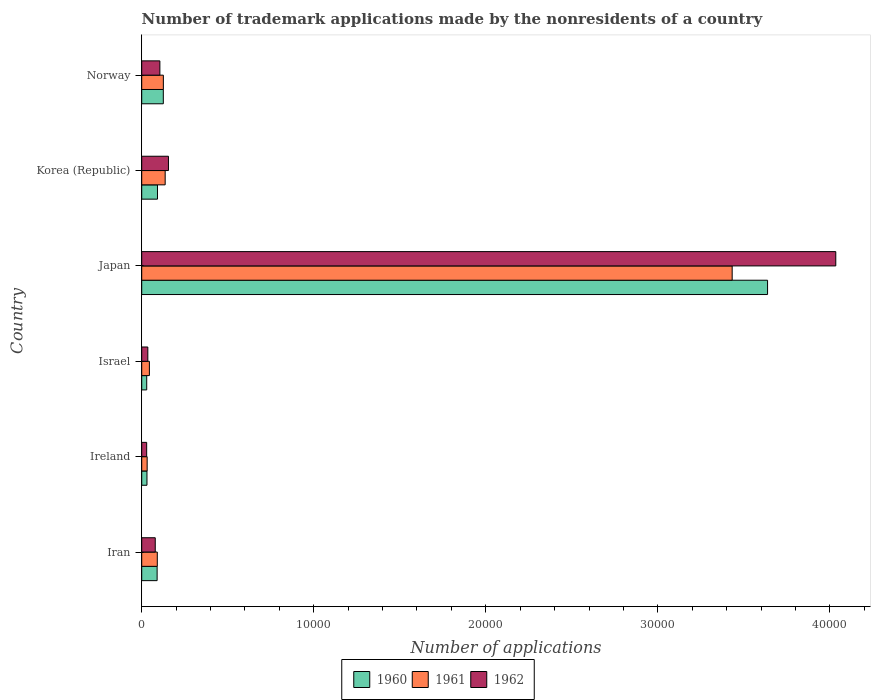How many groups of bars are there?
Give a very brief answer. 6. Are the number of bars per tick equal to the number of legend labels?
Give a very brief answer. Yes. How many bars are there on the 2nd tick from the top?
Provide a short and direct response. 3. How many bars are there on the 6th tick from the bottom?
Offer a very short reply. 3. What is the label of the 4th group of bars from the top?
Provide a short and direct response. Israel. What is the number of trademark applications made by the nonresidents in 1961 in Ireland?
Your response must be concise. 316. Across all countries, what is the maximum number of trademark applications made by the nonresidents in 1961?
Keep it short and to the point. 3.43e+04. Across all countries, what is the minimum number of trademark applications made by the nonresidents in 1962?
Keep it short and to the point. 288. In which country was the number of trademark applications made by the nonresidents in 1961 maximum?
Make the answer very short. Japan. In which country was the number of trademark applications made by the nonresidents in 1962 minimum?
Your answer should be very brief. Ireland. What is the total number of trademark applications made by the nonresidents in 1960 in the graph?
Ensure brevity in your answer.  4.00e+04. What is the difference between the number of trademark applications made by the nonresidents in 1961 in Japan and that in Norway?
Your answer should be compact. 3.31e+04. What is the difference between the number of trademark applications made by the nonresidents in 1961 in Israel and the number of trademark applications made by the nonresidents in 1962 in Iran?
Offer a terse response. -340. What is the average number of trademark applications made by the nonresidents in 1961 per country?
Keep it short and to the point. 6434.67. What is the difference between the number of trademark applications made by the nonresidents in 1962 and number of trademark applications made by the nonresidents in 1960 in Japan?
Your response must be concise. 3966. What is the ratio of the number of trademark applications made by the nonresidents in 1961 in Japan to that in Korea (Republic)?
Provide a short and direct response. 25.18. Is the number of trademark applications made by the nonresidents in 1960 in Israel less than that in Norway?
Provide a succinct answer. Yes. Is the difference between the number of trademark applications made by the nonresidents in 1962 in Iran and Korea (Republic) greater than the difference between the number of trademark applications made by the nonresidents in 1960 in Iran and Korea (Republic)?
Keep it short and to the point. No. What is the difference between the highest and the second highest number of trademark applications made by the nonresidents in 1960?
Give a very brief answer. 3.51e+04. What is the difference between the highest and the lowest number of trademark applications made by the nonresidents in 1961?
Offer a terse response. 3.40e+04. What does the 3rd bar from the bottom in Ireland represents?
Ensure brevity in your answer.  1962. How many bars are there?
Offer a terse response. 18. Are all the bars in the graph horizontal?
Give a very brief answer. Yes. What is the difference between two consecutive major ticks on the X-axis?
Offer a terse response. 10000. Does the graph contain any zero values?
Keep it short and to the point. No. Does the graph contain grids?
Your answer should be compact. No. What is the title of the graph?
Ensure brevity in your answer.  Number of trademark applications made by the nonresidents of a country. Does "2010" appear as one of the legend labels in the graph?
Provide a short and direct response. No. What is the label or title of the X-axis?
Keep it short and to the point. Number of applications. What is the label or title of the Y-axis?
Provide a short and direct response. Country. What is the Number of applications of 1960 in Iran?
Ensure brevity in your answer.  895. What is the Number of applications in 1961 in Iran?
Your answer should be very brief. 905. What is the Number of applications in 1962 in Iran?
Ensure brevity in your answer.  786. What is the Number of applications in 1960 in Ireland?
Your response must be concise. 305. What is the Number of applications of 1961 in Ireland?
Keep it short and to the point. 316. What is the Number of applications of 1962 in Ireland?
Give a very brief answer. 288. What is the Number of applications in 1960 in Israel?
Keep it short and to the point. 290. What is the Number of applications of 1961 in Israel?
Offer a terse response. 446. What is the Number of applications in 1962 in Israel?
Provide a succinct answer. 355. What is the Number of applications in 1960 in Japan?
Offer a very short reply. 3.64e+04. What is the Number of applications in 1961 in Japan?
Offer a terse response. 3.43e+04. What is the Number of applications in 1962 in Japan?
Give a very brief answer. 4.03e+04. What is the Number of applications of 1960 in Korea (Republic)?
Offer a very short reply. 916. What is the Number of applications in 1961 in Korea (Republic)?
Make the answer very short. 1363. What is the Number of applications of 1962 in Korea (Republic)?
Make the answer very short. 1554. What is the Number of applications in 1960 in Norway?
Your response must be concise. 1255. What is the Number of applications of 1961 in Norway?
Offer a very short reply. 1258. What is the Number of applications of 1962 in Norway?
Your response must be concise. 1055. Across all countries, what is the maximum Number of applications in 1960?
Your response must be concise. 3.64e+04. Across all countries, what is the maximum Number of applications in 1961?
Give a very brief answer. 3.43e+04. Across all countries, what is the maximum Number of applications of 1962?
Make the answer very short. 4.03e+04. Across all countries, what is the minimum Number of applications in 1960?
Make the answer very short. 290. Across all countries, what is the minimum Number of applications in 1961?
Give a very brief answer. 316. Across all countries, what is the minimum Number of applications in 1962?
Provide a short and direct response. 288. What is the total Number of applications of 1960 in the graph?
Ensure brevity in your answer.  4.00e+04. What is the total Number of applications of 1961 in the graph?
Provide a succinct answer. 3.86e+04. What is the total Number of applications of 1962 in the graph?
Provide a succinct answer. 4.44e+04. What is the difference between the Number of applications in 1960 in Iran and that in Ireland?
Your answer should be very brief. 590. What is the difference between the Number of applications of 1961 in Iran and that in Ireland?
Keep it short and to the point. 589. What is the difference between the Number of applications in 1962 in Iran and that in Ireland?
Keep it short and to the point. 498. What is the difference between the Number of applications of 1960 in Iran and that in Israel?
Offer a very short reply. 605. What is the difference between the Number of applications in 1961 in Iran and that in Israel?
Provide a succinct answer. 459. What is the difference between the Number of applications of 1962 in Iran and that in Israel?
Your answer should be compact. 431. What is the difference between the Number of applications in 1960 in Iran and that in Japan?
Your answer should be compact. -3.55e+04. What is the difference between the Number of applications in 1961 in Iran and that in Japan?
Give a very brief answer. -3.34e+04. What is the difference between the Number of applications in 1962 in Iran and that in Japan?
Your answer should be compact. -3.96e+04. What is the difference between the Number of applications of 1961 in Iran and that in Korea (Republic)?
Give a very brief answer. -458. What is the difference between the Number of applications in 1962 in Iran and that in Korea (Republic)?
Your answer should be compact. -768. What is the difference between the Number of applications of 1960 in Iran and that in Norway?
Provide a short and direct response. -360. What is the difference between the Number of applications of 1961 in Iran and that in Norway?
Ensure brevity in your answer.  -353. What is the difference between the Number of applications of 1962 in Iran and that in Norway?
Give a very brief answer. -269. What is the difference between the Number of applications of 1960 in Ireland and that in Israel?
Make the answer very short. 15. What is the difference between the Number of applications in 1961 in Ireland and that in Israel?
Your response must be concise. -130. What is the difference between the Number of applications of 1962 in Ireland and that in Israel?
Provide a succinct answer. -67. What is the difference between the Number of applications of 1960 in Ireland and that in Japan?
Keep it short and to the point. -3.61e+04. What is the difference between the Number of applications in 1961 in Ireland and that in Japan?
Offer a very short reply. -3.40e+04. What is the difference between the Number of applications of 1962 in Ireland and that in Japan?
Provide a short and direct response. -4.01e+04. What is the difference between the Number of applications in 1960 in Ireland and that in Korea (Republic)?
Ensure brevity in your answer.  -611. What is the difference between the Number of applications of 1961 in Ireland and that in Korea (Republic)?
Give a very brief answer. -1047. What is the difference between the Number of applications in 1962 in Ireland and that in Korea (Republic)?
Your answer should be very brief. -1266. What is the difference between the Number of applications in 1960 in Ireland and that in Norway?
Make the answer very short. -950. What is the difference between the Number of applications of 1961 in Ireland and that in Norway?
Your answer should be compact. -942. What is the difference between the Number of applications of 1962 in Ireland and that in Norway?
Give a very brief answer. -767. What is the difference between the Number of applications in 1960 in Israel and that in Japan?
Ensure brevity in your answer.  -3.61e+04. What is the difference between the Number of applications in 1961 in Israel and that in Japan?
Provide a succinct answer. -3.39e+04. What is the difference between the Number of applications of 1962 in Israel and that in Japan?
Make the answer very short. -4.00e+04. What is the difference between the Number of applications in 1960 in Israel and that in Korea (Republic)?
Ensure brevity in your answer.  -626. What is the difference between the Number of applications of 1961 in Israel and that in Korea (Republic)?
Make the answer very short. -917. What is the difference between the Number of applications in 1962 in Israel and that in Korea (Republic)?
Your answer should be compact. -1199. What is the difference between the Number of applications in 1960 in Israel and that in Norway?
Provide a short and direct response. -965. What is the difference between the Number of applications of 1961 in Israel and that in Norway?
Provide a succinct answer. -812. What is the difference between the Number of applications of 1962 in Israel and that in Norway?
Make the answer very short. -700. What is the difference between the Number of applications of 1960 in Japan and that in Korea (Republic)?
Your response must be concise. 3.55e+04. What is the difference between the Number of applications of 1961 in Japan and that in Korea (Republic)?
Offer a very short reply. 3.30e+04. What is the difference between the Number of applications of 1962 in Japan and that in Korea (Republic)?
Make the answer very short. 3.88e+04. What is the difference between the Number of applications of 1960 in Japan and that in Norway?
Keep it short and to the point. 3.51e+04. What is the difference between the Number of applications of 1961 in Japan and that in Norway?
Your response must be concise. 3.31e+04. What is the difference between the Number of applications in 1962 in Japan and that in Norway?
Your answer should be compact. 3.93e+04. What is the difference between the Number of applications of 1960 in Korea (Republic) and that in Norway?
Your response must be concise. -339. What is the difference between the Number of applications in 1961 in Korea (Republic) and that in Norway?
Provide a short and direct response. 105. What is the difference between the Number of applications in 1962 in Korea (Republic) and that in Norway?
Give a very brief answer. 499. What is the difference between the Number of applications in 1960 in Iran and the Number of applications in 1961 in Ireland?
Ensure brevity in your answer.  579. What is the difference between the Number of applications of 1960 in Iran and the Number of applications of 1962 in Ireland?
Your answer should be compact. 607. What is the difference between the Number of applications in 1961 in Iran and the Number of applications in 1962 in Ireland?
Offer a very short reply. 617. What is the difference between the Number of applications in 1960 in Iran and the Number of applications in 1961 in Israel?
Offer a terse response. 449. What is the difference between the Number of applications of 1960 in Iran and the Number of applications of 1962 in Israel?
Keep it short and to the point. 540. What is the difference between the Number of applications in 1961 in Iran and the Number of applications in 1962 in Israel?
Ensure brevity in your answer.  550. What is the difference between the Number of applications of 1960 in Iran and the Number of applications of 1961 in Japan?
Make the answer very short. -3.34e+04. What is the difference between the Number of applications of 1960 in Iran and the Number of applications of 1962 in Japan?
Provide a short and direct response. -3.94e+04. What is the difference between the Number of applications in 1961 in Iran and the Number of applications in 1962 in Japan?
Provide a succinct answer. -3.94e+04. What is the difference between the Number of applications of 1960 in Iran and the Number of applications of 1961 in Korea (Republic)?
Ensure brevity in your answer.  -468. What is the difference between the Number of applications in 1960 in Iran and the Number of applications in 1962 in Korea (Republic)?
Offer a very short reply. -659. What is the difference between the Number of applications in 1961 in Iran and the Number of applications in 1962 in Korea (Republic)?
Offer a terse response. -649. What is the difference between the Number of applications of 1960 in Iran and the Number of applications of 1961 in Norway?
Offer a terse response. -363. What is the difference between the Number of applications in 1960 in Iran and the Number of applications in 1962 in Norway?
Offer a terse response. -160. What is the difference between the Number of applications in 1961 in Iran and the Number of applications in 1962 in Norway?
Offer a terse response. -150. What is the difference between the Number of applications of 1960 in Ireland and the Number of applications of 1961 in Israel?
Your answer should be compact. -141. What is the difference between the Number of applications of 1961 in Ireland and the Number of applications of 1962 in Israel?
Make the answer very short. -39. What is the difference between the Number of applications of 1960 in Ireland and the Number of applications of 1961 in Japan?
Provide a short and direct response. -3.40e+04. What is the difference between the Number of applications in 1960 in Ireland and the Number of applications in 1962 in Japan?
Your response must be concise. -4.00e+04. What is the difference between the Number of applications of 1961 in Ireland and the Number of applications of 1962 in Japan?
Offer a terse response. -4.00e+04. What is the difference between the Number of applications of 1960 in Ireland and the Number of applications of 1961 in Korea (Republic)?
Provide a short and direct response. -1058. What is the difference between the Number of applications of 1960 in Ireland and the Number of applications of 1962 in Korea (Republic)?
Your answer should be very brief. -1249. What is the difference between the Number of applications of 1961 in Ireland and the Number of applications of 1962 in Korea (Republic)?
Your response must be concise. -1238. What is the difference between the Number of applications of 1960 in Ireland and the Number of applications of 1961 in Norway?
Provide a short and direct response. -953. What is the difference between the Number of applications of 1960 in Ireland and the Number of applications of 1962 in Norway?
Your answer should be compact. -750. What is the difference between the Number of applications in 1961 in Ireland and the Number of applications in 1962 in Norway?
Your answer should be very brief. -739. What is the difference between the Number of applications of 1960 in Israel and the Number of applications of 1961 in Japan?
Your answer should be very brief. -3.40e+04. What is the difference between the Number of applications in 1960 in Israel and the Number of applications in 1962 in Japan?
Offer a very short reply. -4.01e+04. What is the difference between the Number of applications of 1961 in Israel and the Number of applications of 1962 in Japan?
Your response must be concise. -3.99e+04. What is the difference between the Number of applications of 1960 in Israel and the Number of applications of 1961 in Korea (Republic)?
Keep it short and to the point. -1073. What is the difference between the Number of applications in 1960 in Israel and the Number of applications in 1962 in Korea (Republic)?
Offer a very short reply. -1264. What is the difference between the Number of applications in 1961 in Israel and the Number of applications in 1962 in Korea (Republic)?
Provide a succinct answer. -1108. What is the difference between the Number of applications of 1960 in Israel and the Number of applications of 1961 in Norway?
Give a very brief answer. -968. What is the difference between the Number of applications of 1960 in Israel and the Number of applications of 1962 in Norway?
Your answer should be very brief. -765. What is the difference between the Number of applications in 1961 in Israel and the Number of applications in 1962 in Norway?
Your response must be concise. -609. What is the difference between the Number of applications in 1960 in Japan and the Number of applications in 1961 in Korea (Republic)?
Your answer should be compact. 3.50e+04. What is the difference between the Number of applications of 1960 in Japan and the Number of applications of 1962 in Korea (Republic)?
Give a very brief answer. 3.48e+04. What is the difference between the Number of applications in 1961 in Japan and the Number of applications in 1962 in Korea (Republic)?
Make the answer very short. 3.28e+04. What is the difference between the Number of applications of 1960 in Japan and the Number of applications of 1961 in Norway?
Your answer should be very brief. 3.51e+04. What is the difference between the Number of applications of 1960 in Japan and the Number of applications of 1962 in Norway?
Give a very brief answer. 3.53e+04. What is the difference between the Number of applications in 1961 in Japan and the Number of applications in 1962 in Norway?
Give a very brief answer. 3.33e+04. What is the difference between the Number of applications in 1960 in Korea (Republic) and the Number of applications in 1961 in Norway?
Keep it short and to the point. -342. What is the difference between the Number of applications in 1960 in Korea (Republic) and the Number of applications in 1962 in Norway?
Your answer should be very brief. -139. What is the difference between the Number of applications of 1961 in Korea (Republic) and the Number of applications of 1962 in Norway?
Provide a succinct answer. 308. What is the average Number of applications in 1960 per country?
Your response must be concise. 6673. What is the average Number of applications of 1961 per country?
Provide a succinct answer. 6434.67. What is the average Number of applications of 1962 per country?
Your answer should be compact. 7396.83. What is the difference between the Number of applications of 1960 and Number of applications of 1962 in Iran?
Provide a short and direct response. 109. What is the difference between the Number of applications in 1961 and Number of applications in 1962 in Iran?
Provide a short and direct response. 119. What is the difference between the Number of applications in 1961 and Number of applications in 1962 in Ireland?
Provide a short and direct response. 28. What is the difference between the Number of applications in 1960 and Number of applications in 1961 in Israel?
Give a very brief answer. -156. What is the difference between the Number of applications in 1960 and Number of applications in 1962 in Israel?
Ensure brevity in your answer.  -65. What is the difference between the Number of applications in 1961 and Number of applications in 1962 in Israel?
Make the answer very short. 91. What is the difference between the Number of applications in 1960 and Number of applications in 1961 in Japan?
Offer a terse response. 2057. What is the difference between the Number of applications in 1960 and Number of applications in 1962 in Japan?
Ensure brevity in your answer.  -3966. What is the difference between the Number of applications in 1961 and Number of applications in 1962 in Japan?
Keep it short and to the point. -6023. What is the difference between the Number of applications of 1960 and Number of applications of 1961 in Korea (Republic)?
Your answer should be very brief. -447. What is the difference between the Number of applications of 1960 and Number of applications of 1962 in Korea (Republic)?
Give a very brief answer. -638. What is the difference between the Number of applications of 1961 and Number of applications of 1962 in Korea (Republic)?
Ensure brevity in your answer.  -191. What is the difference between the Number of applications of 1961 and Number of applications of 1962 in Norway?
Give a very brief answer. 203. What is the ratio of the Number of applications of 1960 in Iran to that in Ireland?
Your answer should be compact. 2.93. What is the ratio of the Number of applications in 1961 in Iran to that in Ireland?
Provide a succinct answer. 2.86. What is the ratio of the Number of applications in 1962 in Iran to that in Ireland?
Provide a succinct answer. 2.73. What is the ratio of the Number of applications of 1960 in Iran to that in Israel?
Provide a succinct answer. 3.09. What is the ratio of the Number of applications in 1961 in Iran to that in Israel?
Ensure brevity in your answer.  2.03. What is the ratio of the Number of applications of 1962 in Iran to that in Israel?
Offer a terse response. 2.21. What is the ratio of the Number of applications of 1960 in Iran to that in Japan?
Keep it short and to the point. 0.02. What is the ratio of the Number of applications in 1961 in Iran to that in Japan?
Your answer should be compact. 0.03. What is the ratio of the Number of applications of 1962 in Iran to that in Japan?
Offer a very short reply. 0.02. What is the ratio of the Number of applications in 1960 in Iran to that in Korea (Republic)?
Provide a succinct answer. 0.98. What is the ratio of the Number of applications in 1961 in Iran to that in Korea (Republic)?
Provide a short and direct response. 0.66. What is the ratio of the Number of applications of 1962 in Iran to that in Korea (Republic)?
Give a very brief answer. 0.51. What is the ratio of the Number of applications in 1960 in Iran to that in Norway?
Provide a succinct answer. 0.71. What is the ratio of the Number of applications of 1961 in Iran to that in Norway?
Keep it short and to the point. 0.72. What is the ratio of the Number of applications in 1962 in Iran to that in Norway?
Make the answer very short. 0.74. What is the ratio of the Number of applications in 1960 in Ireland to that in Israel?
Your answer should be compact. 1.05. What is the ratio of the Number of applications of 1961 in Ireland to that in Israel?
Keep it short and to the point. 0.71. What is the ratio of the Number of applications in 1962 in Ireland to that in Israel?
Your answer should be compact. 0.81. What is the ratio of the Number of applications in 1960 in Ireland to that in Japan?
Give a very brief answer. 0.01. What is the ratio of the Number of applications of 1961 in Ireland to that in Japan?
Make the answer very short. 0.01. What is the ratio of the Number of applications in 1962 in Ireland to that in Japan?
Provide a short and direct response. 0.01. What is the ratio of the Number of applications of 1960 in Ireland to that in Korea (Republic)?
Make the answer very short. 0.33. What is the ratio of the Number of applications in 1961 in Ireland to that in Korea (Republic)?
Offer a terse response. 0.23. What is the ratio of the Number of applications in 1962 in Ireland to that in Korea (Republic)?
Your response must be concise. 0.19. What is the ratio of the Number of applications of 1960 in Ireland to that in Norway?
Give a very brief answer. 0.24. What is the ratio of the Number of applications in 1961 in Ireland to that in Norway?
Provide a short and direct response. 0.25. What is the ratio of the Number of applications of 1962 in Ireland to that in Norway?
Your response must be concise. 0.27. What is the ratio of the Number of applications of 1960 in Israel to that in Japan?
Your response must be concise. 0.01. What is the ratio of the Number of applications of 1961 in Israel to that in Japan?
Make the answer very short. 0.01. What is the ratio of the Number of applications of 1962 in Israel to that in Japan?
Keep it short and to the point. 0.01. What is the ratio of the Number of applications of 1960 in Israel to that in Korea (Republic)?
Ensure brevity in your answer.  0.32. What is the ratio of the Number of applications in 1961 in Israel to that in Korea (Republic)?
Offer a terse response. 0.33. What is the ratio of the Number of applications of 1962 in Israel to that in Korea (Republic)?
Your answer should be very brief. 0.23. What is the ratio of the Number of applications of 1960 in Israel to that in Norway?
Provide a succinct answer. 0.23. What is the ratio of the Number of applications of 1961 in Israel to that in Norway?
Offer a terse response. 0.35. What is the ratio of the Number of applications of 1962 in Israel to that in Norway?
Your response must be concise. 0.34. What is the ratio of the Number of applications of 1960 in Japan to that in Korea (Republic)?
Provide a short and direct response. 39.71. What is the ratio of the Number of applications of 1961 in Japan to that in Korea (Republic)?
Provide a short and direct response. 25.18. What is the ratio of the Number of applications of 1962 in Japan to that in Korea (Republic)?
Your response must be concise. 25.96. What is the ratio of the Number of applications in 1960 in Japan to that in Norway?
Your answer should be very brief. 28.99. What is the ratio of the Number of applications in 1961 in Japan to that in Norway?
Give a very brief answer. 27.28. What is the ratio of the Number of applications in 1962 in Japan to that in Norway?
Provide a short and direct response. 38.24. What is the ratio of the Number of applications in 1960 in Korea (Republic) to that in Norway?
Provide a succinct answer. 0.73. What is the ratio of the Number of applications of 1961 in Korea (Republic) to that in Norway?
Offer a terse response. 1.08. What is the ratio of the Number of applications of 1962 in Korea (Republic) to that in Norway?
Your response must be concise. 1.47. What is the difference between the highest and the second highest Number of applications of 1960?
Provide a succinct answer. 3.51e+04. What is the difference between the highest and the second highest Number of applications in 1961?
Ensure brevity in your answer.  3.30e+04. What is the difference between the highest and the second highest Number of applications of 1962?
Make the answer very short. 3.88e+04. What is the difference between the highest and the lowest Number of applications of 1960?
Offer a very short reply. 3.61e+04. What is the difference between the highest and the lowest Number of applications in 1961?
Your answer should be very brief. 3.40e+04. What is the difference between the highest and the lowest Number of applications in 1962?
Ensure brevity in your answer.  4.01e+04. 